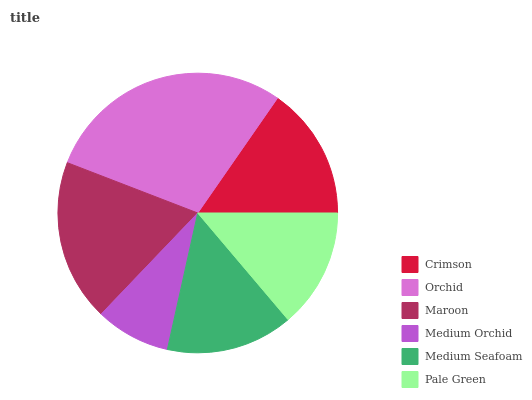Is Medium Orchid the minimum?
Answer yes or no. Yes. Is Orchid the maximum?
Answer yes or no. Yes. Is Maroon the minimum?
Answer yes or no. No. Is Maroon the maximum?
Answer yes or no. No. Is Orchid greater than Maroon?
Answer yes or no. Yes. Is Maroon less than Orchid?
Answer yes or no. Yes. Is Maroon greater than Orchid?
Answer yes or no. No. Is Orchid less than Maroon?
Answer yes or no. No. Is Crimson the high median?
Answer yes or no. Yes. Is Medium Seafoam the low median?
Answer yes or no. Yes. Is Maroon the high median?
Answer yes or no. No. Is Crimson the low median?
Answer yes or no. No. 